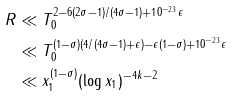<formula> <loc_0><loc_0><loc_500><loc_500>R & \ll T _ { 0 } ^ { 2 - 6 ( 2 \sigma - 1 ) / ( 4 \sigma - 1 ) + 1 0 ^ { - 2 3 } \epsilon } \\ & \ll T _ { 0 } ^ { ( 1 - \sigma ) ( 4 / ( 4 \sigma - 1 ) + \epsilon ) - \epsilon ( 1 - \sigma ) + 1 0 ^ { - 2 3 } \epsilon } \\ & \ll x _ { 1 } ^ { ( 1 - \sigma ) } ( \log { x _ { 1 } } ) ^ { - 4 k - 2 }</formula> 